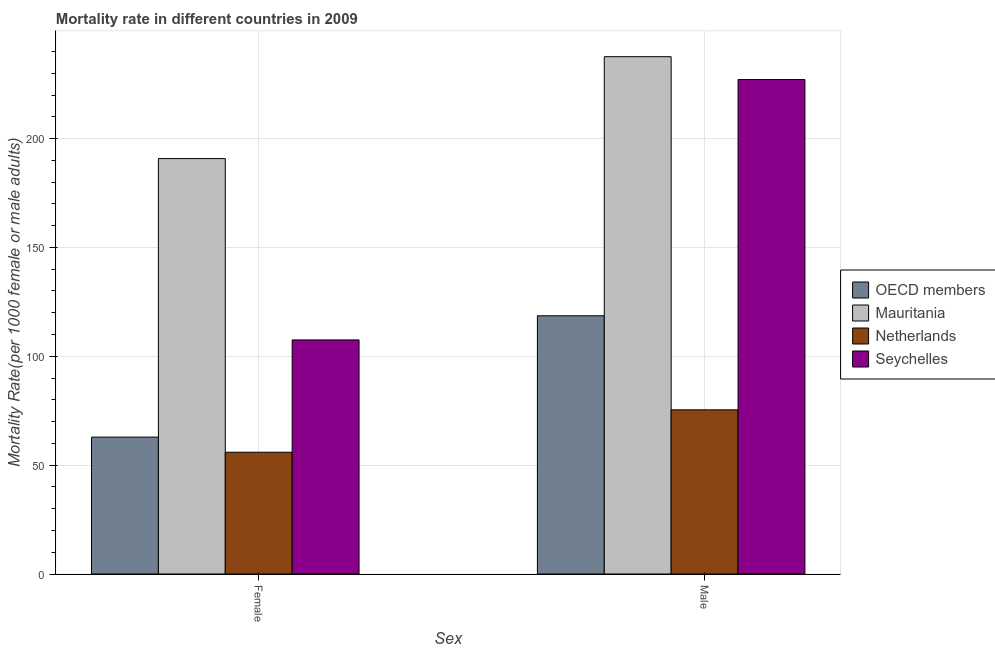How many different coloured bars are there?
Make the answer very short. 4. How many groups of bars are there?
Provide a short and direct response. 2. How many bars are there on the 1st tick from the left?
Your answer should be very brief. 4. What is the male mortality rate in Netherlands?
Ensure brevity in your answer.  75.4. Across all countries, what is the maximum female mortality rate?
Your response must be concise. 190.8. Across all countries, what is the minimum male mortality rate?
Offer a terse response. 75.4. In which country was the male mortality rate maximum?
Offer a terse response. Mauritania. What is the total male mortality rate in the graph?
Provide a succinct answer. 658.72. What is the difference between the female mortality rate in Mauritania and that in Netherlands?
Provide a succinct answer. 134.88. What is the difference between the female mortality rate in Netherlands and the male mortality rate in OECD members?
Make the answer very short. -62.68. What is the average male mortality rate per country?
Your response must be concise. 164.68. What is the difference between the male mortality rate and female mortality rate in Seychelles?
Offer a terse response. 119.61. In how many countries, is the male mortality rate greater than 120 ?
Keep it short and to the point. 2. What is the ratio of the female mortality rate in Mauritania to that in Netherlands?
Provide a succinct answer. 3.41. In how many countries, is the male mortality rate greater than the average male mortality rate taken over all countries?
Your response must be concise. 2. What does the 2nd bar from the right in Female represents?
Your answer should be compact. Netherlands. How many bars are there?
Your response must be concise. 8. Are the values on the major ticks of Y-axis written in scientific E-notation?
Offer a very short reply. No. Does the graph contain grids?
Offer a terse response. Yes. How are the legend labels stacked?
Ensure brevity in your answer.  Vertical. What is the title of the graph?
Your answer should be compact. Mortality rate in different countries in 2009. What is the label or title of the X-axis?
Your answer should be very brief. Sex. What is the label or title of the Y-axis?
Your response must be concise. Mortality Rate(per 1000 female or male adults). What is the Mortality Rate(per 1000 female or male adults) in OECD members in Female?
Offer a very short reply. 62.87. What is the Mortality Rate(per 1000 female or male adults) of Mauritania in Female?
Provide a succinct answer. 190.8. What is the Mortality Rate(per 1000 female or male adults) in Netherlands in Female?
Your answer should be compact. 55.92. What is the Mortality Rate(per 1000 female or male adults) in Seychelles in Female?
Make the answer very short. 107.51. What is the Mortality Rate(per 1000 female or male adults) of OECD members in Male?
Give a very brief answer. 118.6. What is the Mortality Rate(per 1000 female or male adults) in Mauritania in Male?
Make the answer very short. 237.6. What is the Mortality Rate(per 1000 female or male adults) in Netherlands in Male?
Your answer should be compact. 75.4. What is the Mortality Rate(per 1000 female or male adults) of Seychelles in Male?
Offer a very short reply. 227.12. Across all Sex, what is the maximum Mortality Rate(per 1000 female or male adults) of OECD members?
Keep it short and to the point. 118.6. Across all Sex, what is the maximum Mortality Rate(per 1000 female or male adults) of Mauritania?
Provide a short and direct response. 237.6. Across all Sex, what is the maximum Mortality Rate(per 1000 female or male adults) in Netherlands?
Offer a terse response. 75.4. Across all Sex, what is the maximum Mortality Rate(per 1000 female or male adults) in Seychelles?
Provide a short and direct response. 227.12. Across all Sex, what is the minimum Mortality Rate(per 1000 female or male adults) of OECD members?
Provide a succinct answer. 62.87. Across all Sex, what is the minimum Mortality Rate(per 1000 female or male adults) of Mauritania?
Keep it short and to the point. 190.8. Across all Sex, what is the minimum Mortality Rate(per 1000 female or male adults) of Netherlands?
Give a very brief answer. 55.92. Across all Sex, what is the minimum Mortality Rate(per 1000 female or male adults) in Seychelles?
Offer a very short reply. 107.51. What is the total Mortality Rate(per 1000 female or male adults) in OECD members in the graph?
Provide a succinct answer. 181.47. What is the total Mortality Rate(per 1000 female or male adults) of Mauritania in the graph?
Ensure brevity in your answer.  428.4. What is the total Mortality Rate(per 1000 female or male adults) in Netherlands in the graph?
Provide a succinct answer. 131.32. What is the total Mortality Rate(per 1000 female or male adults) in Seychelles in the graph?
Provide a succinct answer. 334.63. What is the difference between the Mortality Rate(per 1000 female or male adults) of OECD members in Female and that in Male?
Offer a very short reply. -55.73. What is the difference between the Mortality Rate(per 1000 female or male adults) of Mauritania in Female and that in Male?
Give a very brief answer. -46.8. What is the difference between the Mortality Rate(per 1000 female or male adults) in Netherlands in Female and that in Male?
Your answer should be compact. -19.48. What is the difference between the Mortality Rate(per 1000 female or male adults) in Seychelles in Female and that in Male?
Your response must be concise. -119.61. What is the difference between the Mortality Rate(per 1000 female or male adults) in OECD members in Female and the Mortality Rate(per 1000 female or male adults) in Mauritania in Male?
Your response must be concise. -174.73. What is the difference between the Mortality Rate(per 1000 female or male adults) of OECD members in Female and the Mortality Rate(per 1000 female or male adults) of Netherlands in Male?
Keep it short and to the point. -12.53. What is the difference between the Mortality Rate(per 1000 female or male adults) in OECD members in Female and the Mortality Rate(per 1000 female or male adults) in Seychelles in Male?
Your response must be concise. -164.25. What is the difference between the Mortality Rate(per 1000 female or male adults) of Mauritania in Female and the Mortality Rate(per 1000 female or male adults) of Netherlands in Male?
Give a very brief answer. 115.4. What is the difference between the Mortality Rate(per 1000 female or male adults) of Mauritania in Female and the Mortality Rate(per 1000 female or male adults) of Seychelles in Male?
Offer a terse response. -36.32. What is the difference between the Mortality Rate(per 1000 female or male adults) of Netherlands in Female and the Mortality Rate(per 1000 female or male adults) of Seychelles in Male?
Provide a succinct answer. -171.2. What is the average Mortality Rate(per 1000 female or male adults) in OECD members per Sex?
Offer a terse response. 90.74. What is the average Mortality Rate(per 1000 female or male adults) of Mauritania per Sex?
Provide a short and direct response. 214.2. What is the average Mortality Rate(per 1000 female or male adults) of Netherlands per Sex?
Your response must be concise. 65.66. What is the average Mortality Rate(per 1000 female or male adults) of Seychelles per Sex?
Provide a short and direct response. 167.31. What is the difference between the Mortality Rate(per 1000 female or male adults) in OECD members and Mortality Rate(per 1000 female or male adults) in Mauritania in Female?
Your response must be concise. -127.93. What is the difference between the Mortality Rate(per 1000 female or male adults) of OECD members and Mortality Rate(per 1000 female or male adults) of Netherlands in Female?
Offer a very short reply. 6.95. What is the difference between the Mortality Rate(per 1000 female or male adults) in OECD members and Mortality Rate(per 1000 female or male adults) in Seychelles in Female?
Offer a terse response. -44.64. What is the difference between the Mortality Rate(per 1000 female or male adults) in Mauritania and Mortality Rate(per 1000 female or male adults) in Netherlands in Female?
Give a very brief answer. 134.88. What is the difference between the Mortality Rate(per 1000 female or male adults) of Mauritania and Mortality Rate(per 1000 female or male adults) of Seychelles in Female?
Ensure brevity in your answer.  83.29. What is the difference between the Mortality Rate(per 1000 female or male adults) of Netherlands and Mortality Rate(per 1000 female or male adults) of Seychelles in Female?
Your answer should be very brief. -51.59. What is the difference between the Mortality Rate(per 1000 female or male adults) in OECD members and Mortality Rate(per 1000 female or male adults) in Mauritania in Male?
Provide a succinct answer. -119. What is the difference between the Mortality Rate(per 1000 female or male adults) in OECD members and Mortality Rate(per 1000 female or male adults) in Netherlands in Male?
Your response must be concise. 43.2. What is the difference between the Mortality Rate(per 1000 female or male adults) in OECD members and Mortality Rate(per 1000 female or male adults) in Seychelles in Male?
Your answer should be compact. -108.51. What is the difference between the Mortality Rate(per 1000 female or male adults) of Mauritania and Mortality Rate(per 1000 female or male adults) of Netherlands in Male?
Make the answer very short. 162.2. What is the difference between the Mortality Rate(per 1000 female or male adults) of Mauritania and Mortality Rate(per 1000 female or male adults) of Seychelles in Male?
Provide a short and direct response. 10.48. What is the difference between the Mortality Rate(per 1000 female or male adults) of Netherlands and Mortality Rate(per 1000 female or male adults) of Seychelles in Male?
Ensure brevity in your answer.  -151.72. What is the ratio of the Mortality Rate(per 1000 female or male adults) of OECD members in Female to that in Male?
Make the answer very short. 0.53. What is the ratio of the Mortality Rate(per 1000 female or male adults) in Mauritania in Female to that in Male?
Ensure brevity in your answer.  0.8. What is the ratio of the Mortality Rate(per 1000 female or male adults) in Netherlands in Female to that in Male?
Your response must be concise. 0.74. What is the ratio of the Mortality Rate(per 1000 female or male adults) in Seychelles in Female to that in Male?
Offer a very short reply. 0.47. What is the difference between the highest and the second highest Mortality Rate(per 1000 female or male adults) of OECD members?
Keep it short and to the point. 55.73. What is the difference between the highest and the second highest Mortality Rate(per 1000 female or male adults) in Mauritania?
Give a very brief answer. 46.8. What is the difference between the highest and the second highest Mortality Rate(per 1000 female or male adults) in Netherlands?
Give a very brief answer. 19.48. What is the difference between the highest and the second highest Mortality Rate(per 1000 female or male adults) in Seychelles?
Make the answer very short. 119.61. What is the difference between the highest and the lowest Mortality Rate(per 1000 female or male adults) of OECD members?
Provide a succinct answer. 55.73. What is the difference between the highest and the lowest Mortality Rate(per 1000 female or male adults) in Mauritania?
Provide a short and direct response. 46.8. What is the difference between the highest and the lowest Mortality Rate(per 1000 female or male adults) of Netherlands?
Keep it short and to the point. 19.48. What is the difference between the highest and the lowest Mortality Rate(per 1000 female or male adults) in Seychelles?
Your answer should be very brief. 119.61. 